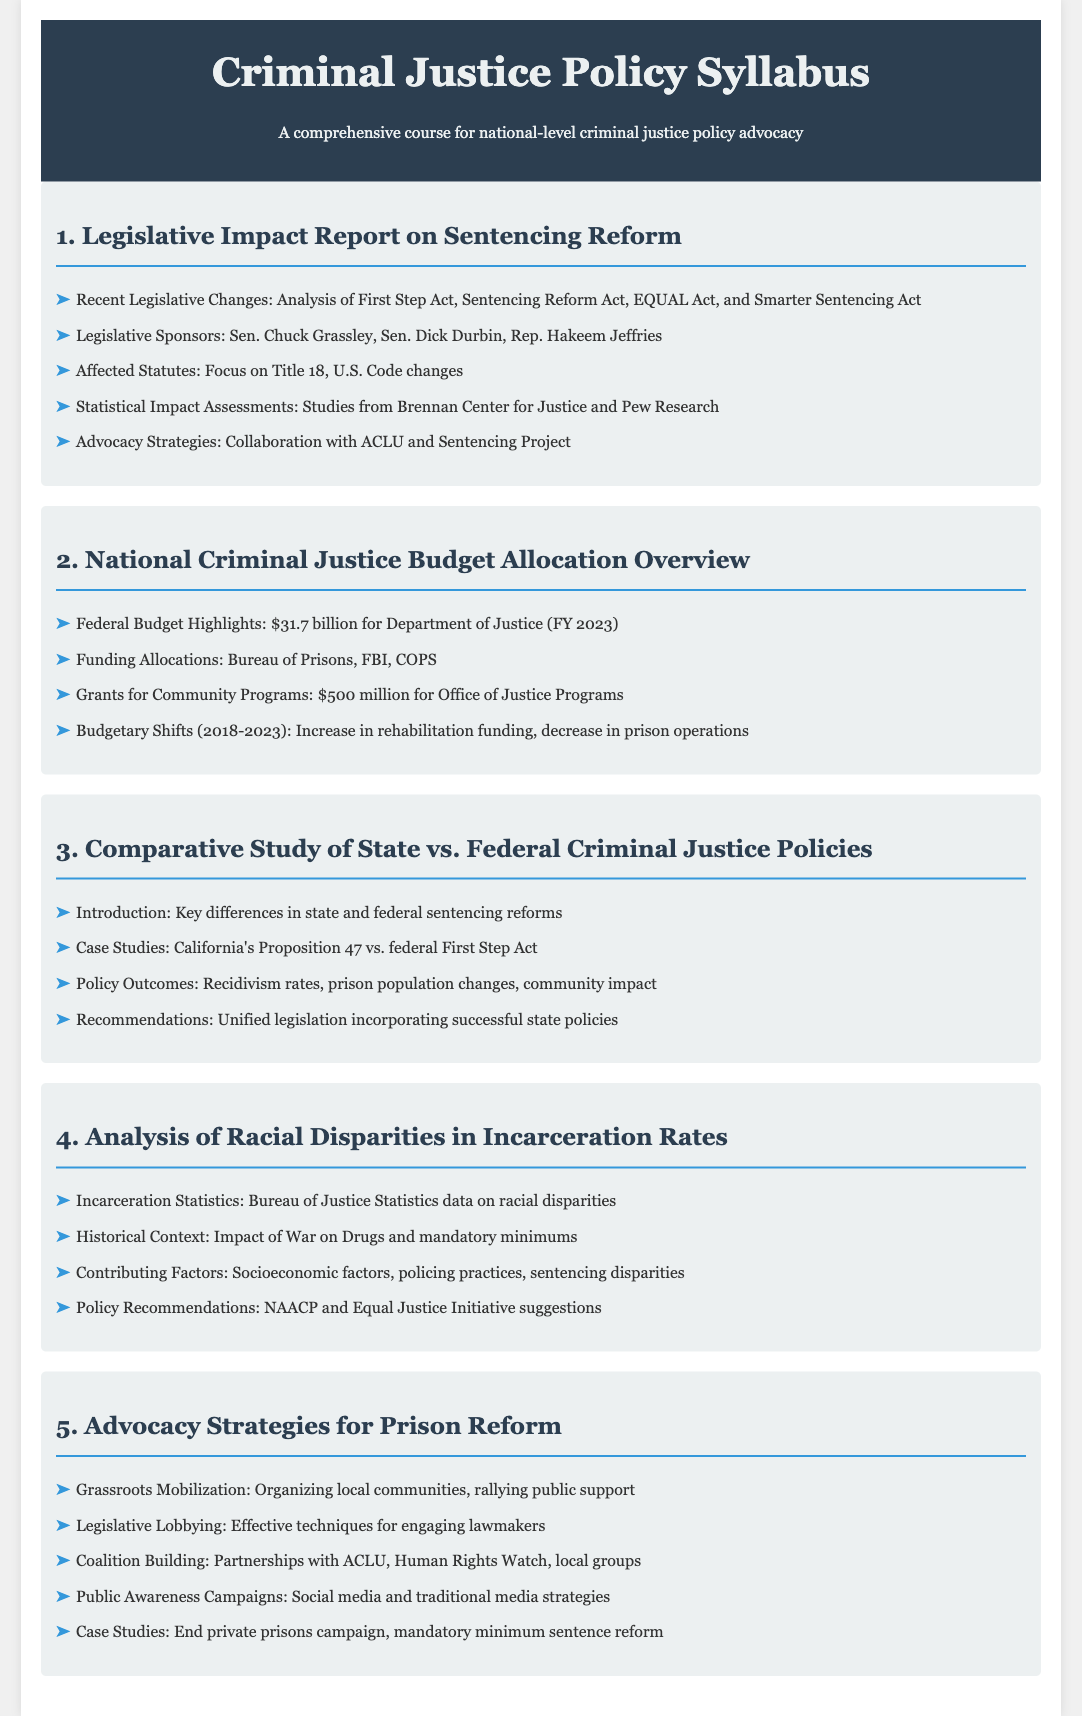What is the total federal criminal justice budget for FY 2023? The document states that the federal criminal justice budget for FY 2023 is $31.7 billion.
Answer: $31.7 billion Who are the legislative sponsors of the recent sentencing reform bills? The document lists Sen. Chuck Grassley, Sen. Dick Durbin, and Rep. Hakeem Jeffries as sponsors.
Answer: Sen. Chuck Grassley, Sen. Dick Durbin, Rep. Hakeem Jeffries What is one key difference discussed between state and federal policies? The syllabus mentions key differences in state and federal sentencing reforms.
Answer: Key differences in state and federal sentencing reforms Which federal act is associated with community program grants? The syllabus highlights $500 million allocated for community programs under the Office of Justice Programs.
Answer: Office of Justice Programs What organization is recommended for collaboration in advocacy strategies? The document recommends collaboration with ACLU in advocacy strategies.
Answer: ACLU How did budget allocations shift from 2018 to 2023? The document points out an increase in rehabilitation funding and a decrease in prison operations.
Answer: Increase in rehabilitation funding, decrease in prison operations What historical context is mentioned regarding racial disparities? The syllabus references the impact of the War on Drugs and mandatory minimums as historical contexts.
Answer: War on Drugs and mandatory minimums Which program focuses on organizing local communities? The document indicates that grassroots mobilization focuses on organizing local communities.
Answer: Grassroots mobilization What case study is mentioned in comparing state and federal policies? The syllabus mentions California's Proposition 47 as a case study.
Answer: California's Proposition 47 